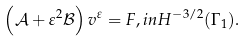<formula> <loc_0><loc_0><loc_500><loc_500>\left ( \mathcal { A } + \varepsilon ^ { 2 } \mathcal { B } \right ) v ^ { \varepsilon } = F , i n H ^ { - 3 / 2 } ( \Gamma _ { 1 } ) .</formula> 